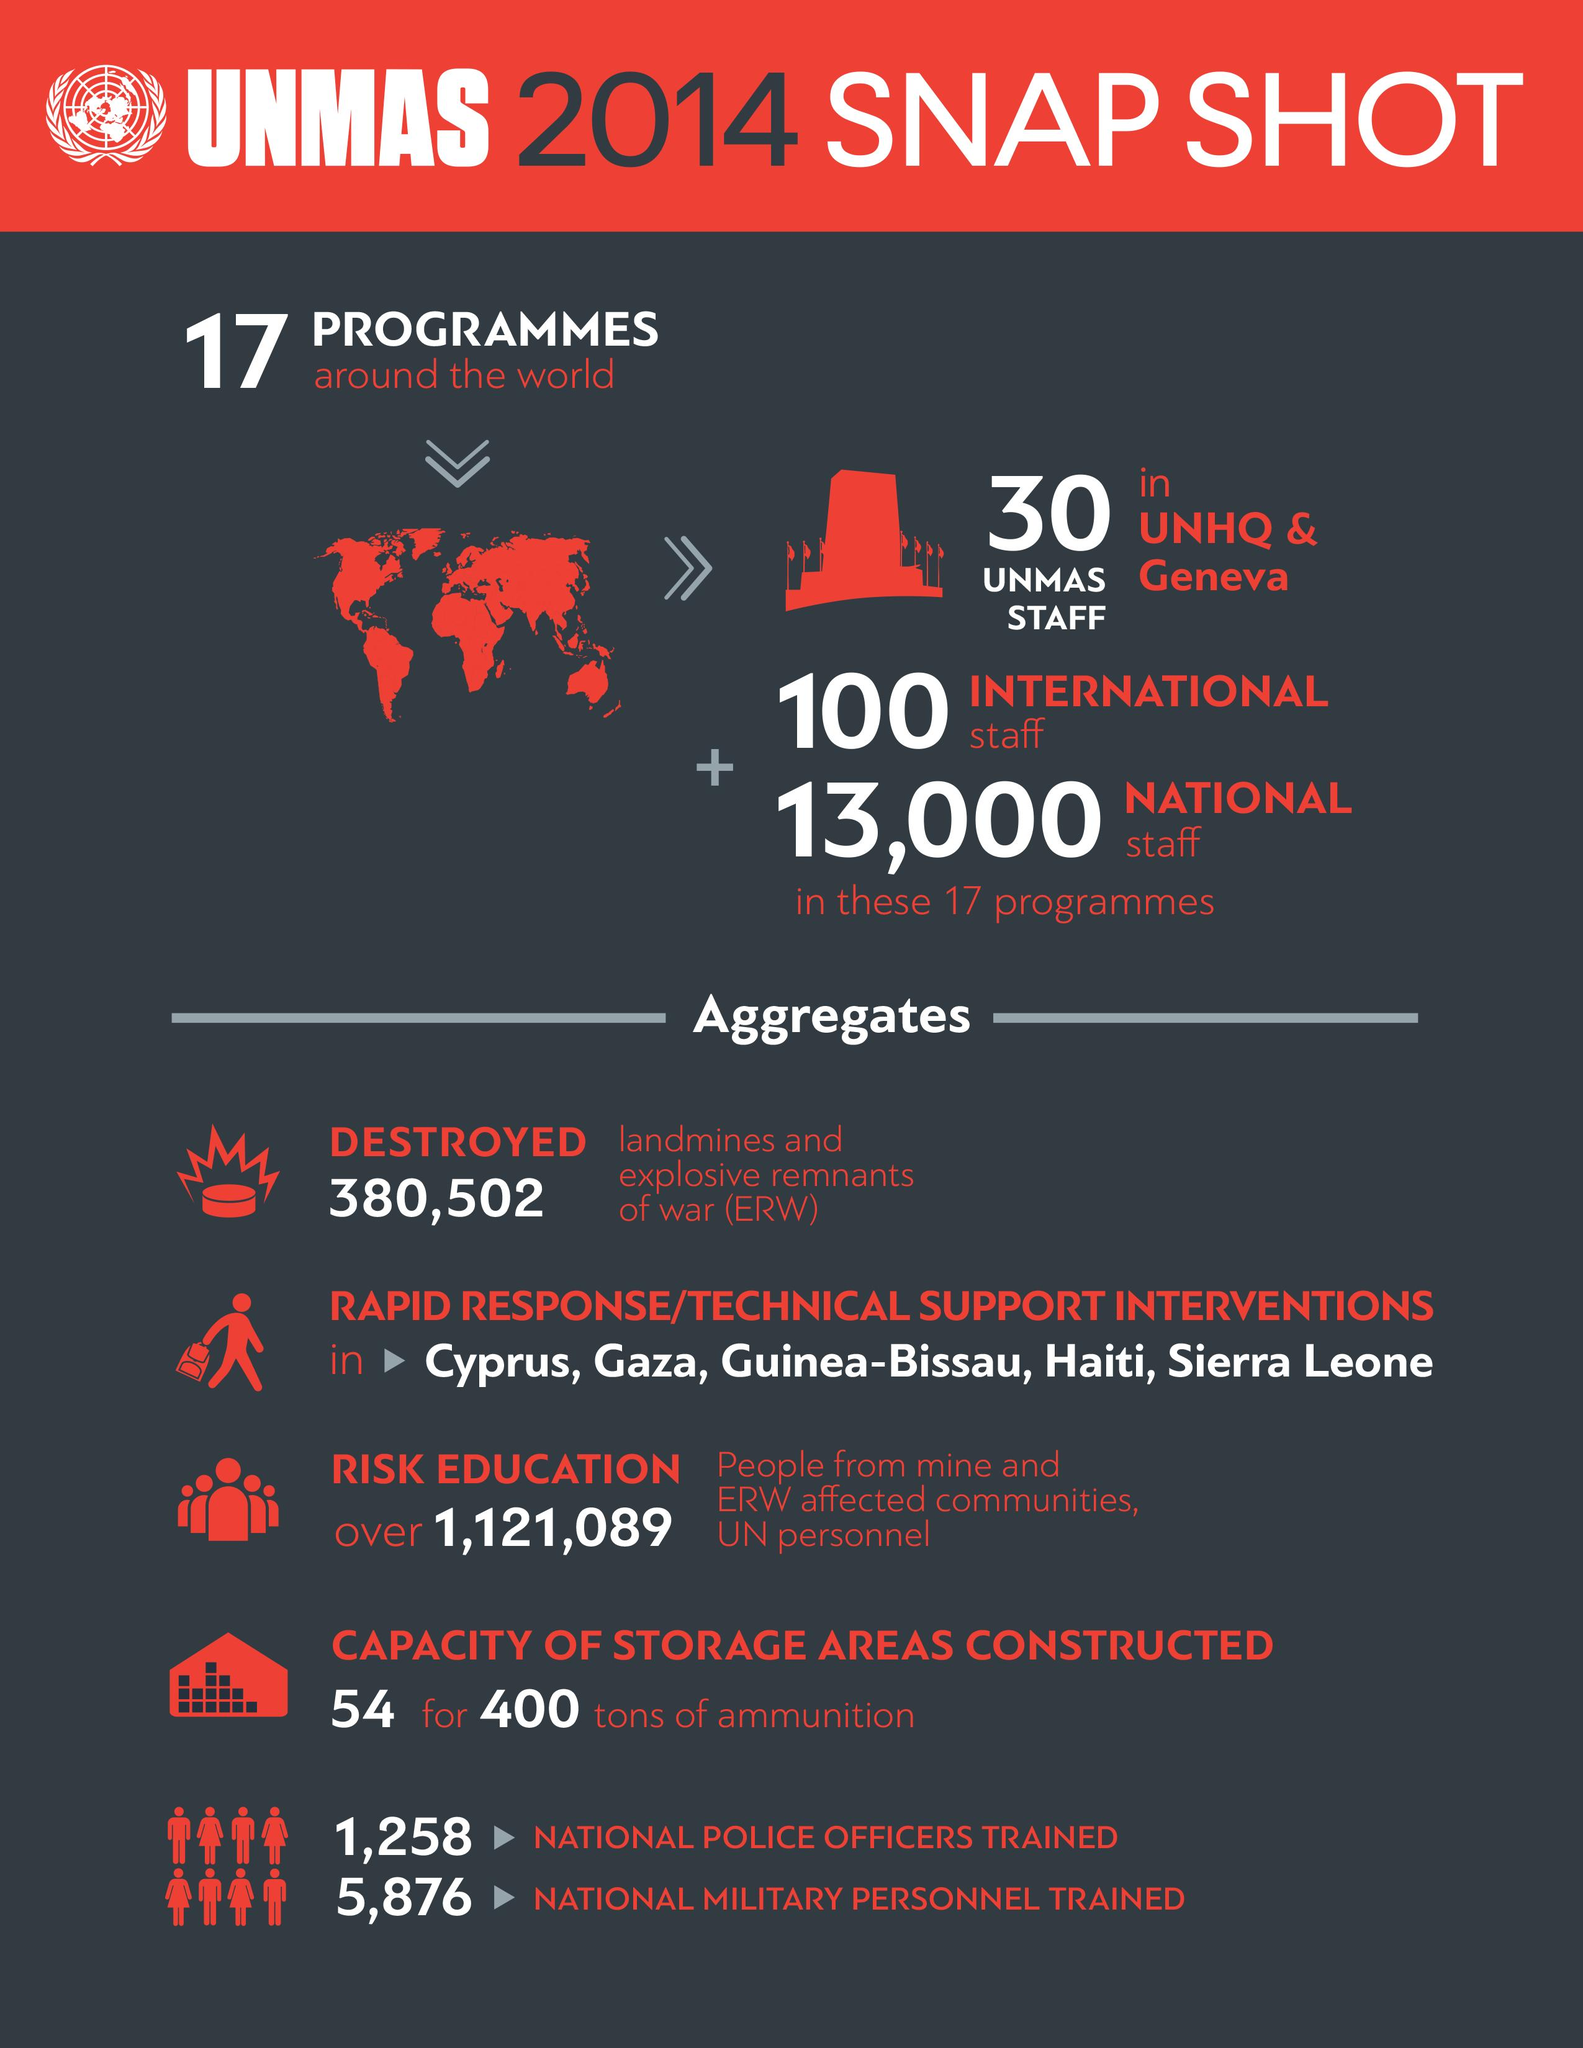List a handful of essential elements in this visual. In total, 7,134 police officers and military personnel have been trained as of 2022. The United Nations has 13,100 national and international staff members working in its 17 programs. According to information provided, UNMAS undertook five rapid response interventions in 2014. The technical support or rapid response interventions were taken in 5 regions. 